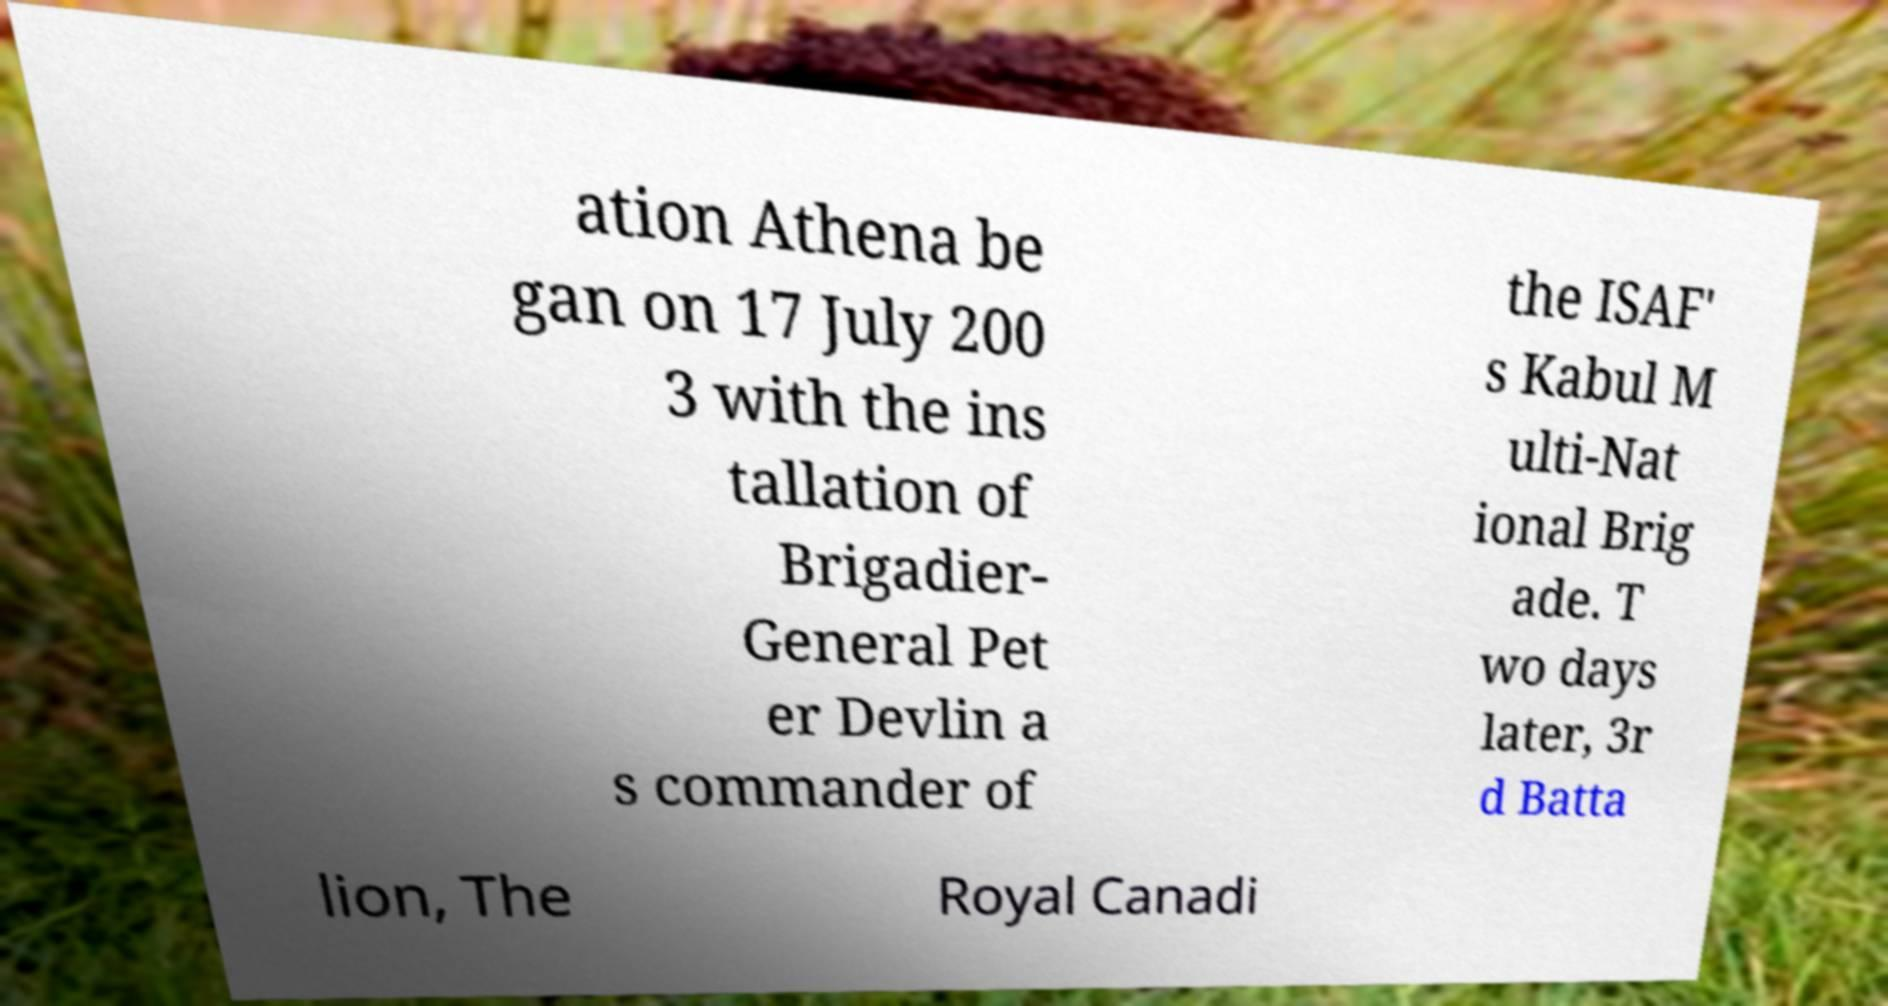Can you accurately transcribe the text from the provided image for me? ation Athena be gan on 17 July 200 3 with the ins tallation of Brigadier- General Pet er Devlin a s commander of the ISAF' s Kabul M ulti-Nat ional Brig ade. T wo days later, 3r d Batta lion, The Royal Canadi 